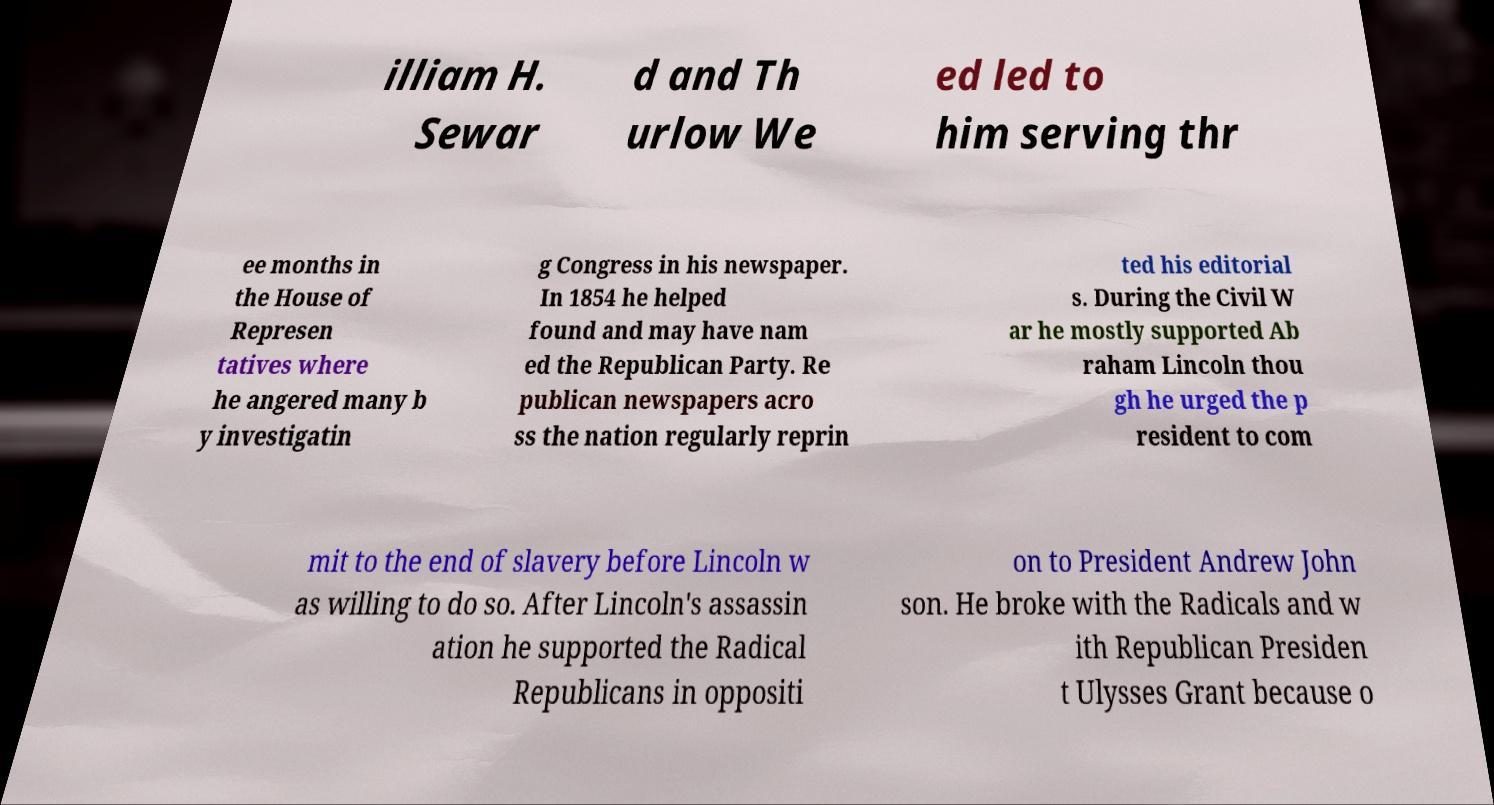For documentation purposes, I need the text within this image transcribed. Could you provide that? illiam H. Sewar d and Th urlow We ed led to him serving thr ee months in the House of Represen tatives where he angered many b y investigatin g Congress in his newspaper. In 1854 he helped found and may have nam ed the Republican Party. Re publican newspapers acro ss the nation regularly reprin ted his editorial s. During the Civil W ar he mostly supported Ab raham Lincoln thou gh he urged the p resident to com mit to the end of slavery before Lincoln w as willing to do so. After Lincoln's assassin ation he supported the Radical Republicans in oppositi on to President Andrew John son. He broke with the Radicals and w ith Republican Presiden t Ulysses Grant because o 